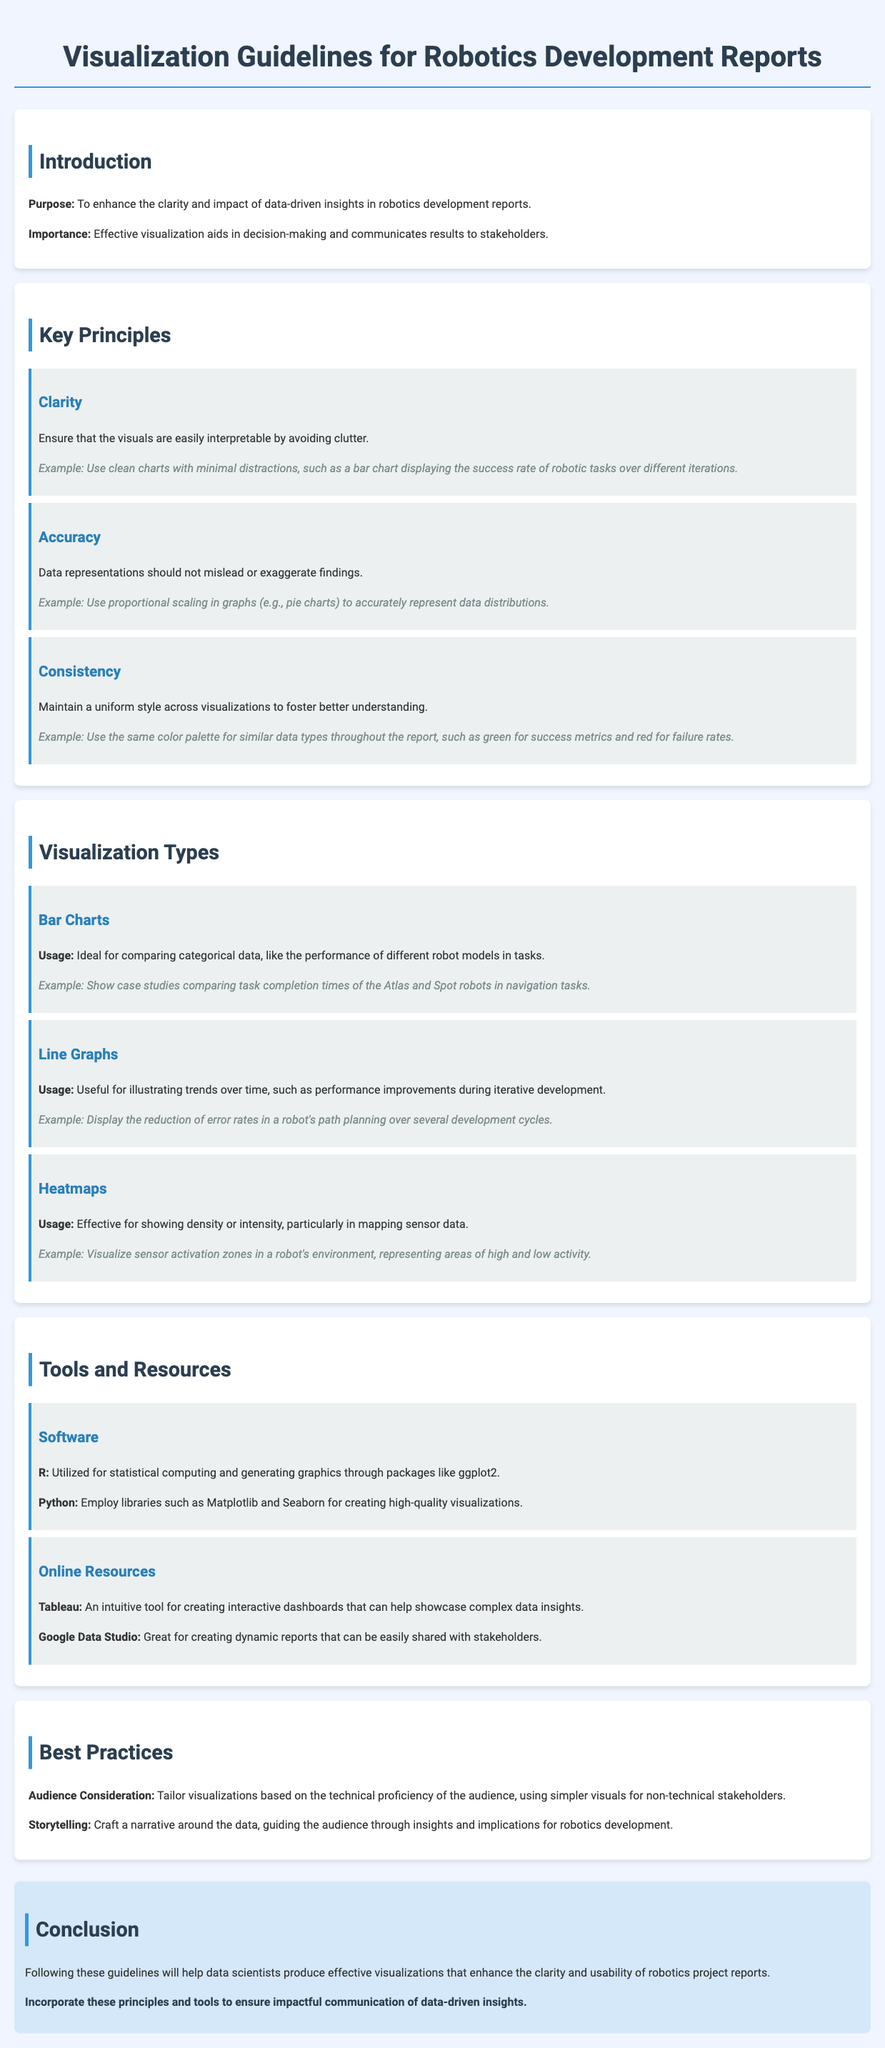What is the purpose of the guidelines? The purpose is mentioned in the introduction section, which states that it is to enhance the clarity and impact of data-driven insights in robotics development reports.
Answer: Enhance the clarity and impact of data-driven insights What are the three key principles of visualization mentioned? The document lists three key principles for visualizations in the key principles section: Clarity, Accuracy, and Consistency.
Answer: Clarity, Accuracy, Consistency What type of visualization is ideal for comparing categorical data? The section on visualization types specifies that Bar Charts are ideal for comparing categorical data.
Answer: Bar Charts What software is suggested for creating high-quality visualizations? The tools and resources section mentions R and Python as software for creating high-quality visualizations.
Answer: R and Python How many example visualizations are mentioned in the document? The document lists three types of visualizations: Bar Charts, Line Graphs, and Heatmaps, each with an example, totaling three examples.
Answer: Three What is one best practice for tailoring visualizations? The best practices section states that visualizations should be tailored based on the technical proficiency of the audience.
Answer: Technical proficiency of the audience What type of visuals should be used for non-technical stakeholders? The best practices section advises using simpler visuals for non-technical stakeholders, as a method to enhance understanding.
Answer: Simpler visuals What is a recommended tool for creating interactive dashboards? The tools and resources section recommends Tableau for creating interactive dashboards.
Answer: Tableau 